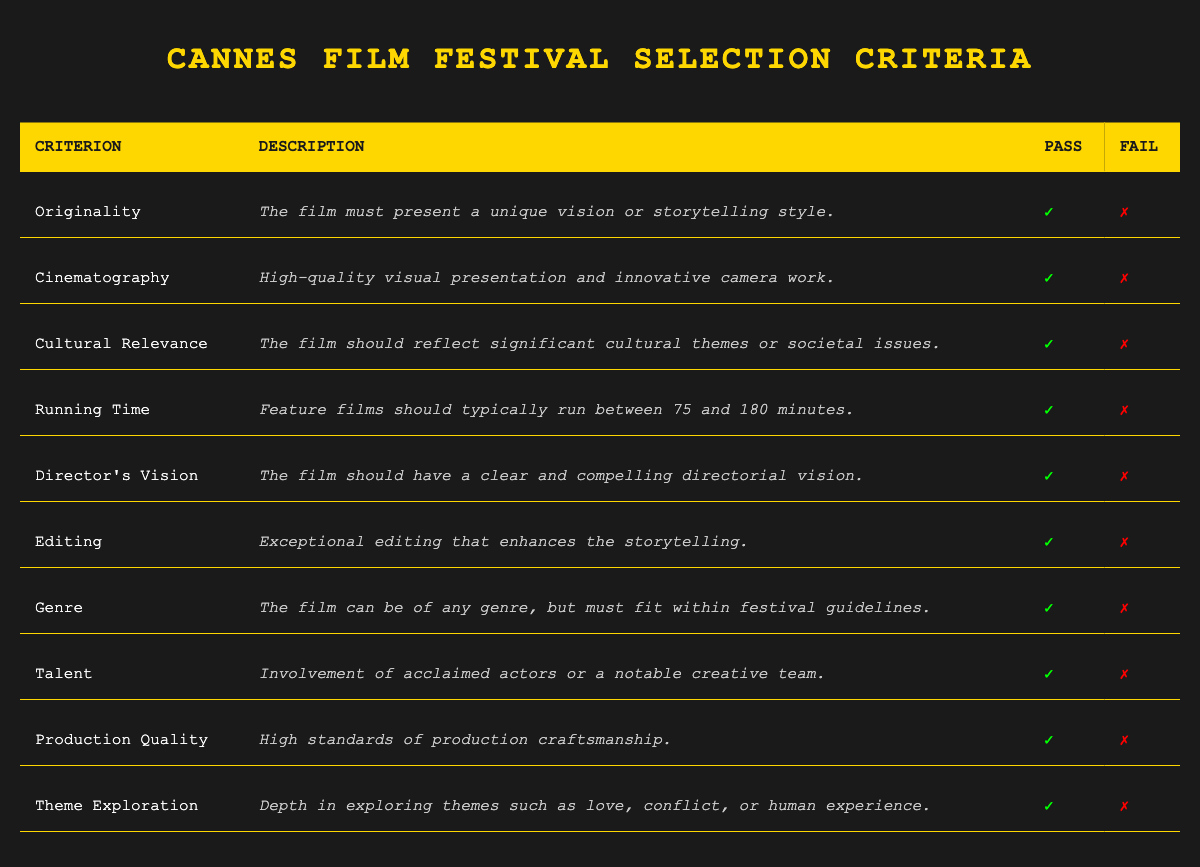What are the criteria for film selection at the Cannes Film Festival? The table lists ten criteria for film selection at the Cannes Film Festival: Originality, Cinematography, Cultural Relevance, Running Time, Director's Vision, Editing, Genre, Talent, Production Quality, and Theme Exploration.
Answer: 10 criteria Which criterion focuses on the storytelling approach? The criterion that focuses on the storytelling approach is Originality, which specifies that the film must present a unique vision or storytelling style.
Answer: Originality Does the table indicate that a film can be of any genre? Yes, the Genre criterion indicates that the film can indeed be of any genre, but must fit within the festival guidelines.
Answer: Yes How many criteria must a film pass to be considered for selection if all criteria must be passed? All films must pass all 10 listed criteria to be considered for selection, as there are no failing criteria in the table. Therefore, a film must pass all 10.
Answer: 10 What is the description provided for "Editing"? The description for Editing states: "Exceptional editing that enhances the storytelling."
Answer: Exceptional editing enhances storytelling If a film passes the Talent criterion but fails the Director’s Vision criterion, will it be selected for the festival? No, it will not be selected because a film must pass all criteria to be eligible for selection, and failing the Director's Vision criterion disqualifies it despite passing the Talent criterion.
Answer: No Which criterion emphasizes the importance of visual presentation? The criterion that emphasizes the importance of visual presentation is Cinematography, which requires high-quality visual presentation and innovative camera work.
Answer: Cinematography Which criteria require a film to reflect societal or cultural issues? The criteria that require the film to reflect societal or cultural issues are Cultural Relevance, which focuses on significant cultural themes or societal issues, and Theme Exploration, which emphasizes depth in examining themes like love or conflict.
Answer: Cultural Relevance and Theme Exploration What is the average number of criteria related to technical aspects (like Cinematography, Editing, and Production Quality)? There are three specific criteria related to technical aspects: Cinematography, Editing, and Production Quality. To find the average, you count the number of technical criteria (3), and since there are no other parameters affecting this value, the average is simply 3.
Answer: 3 